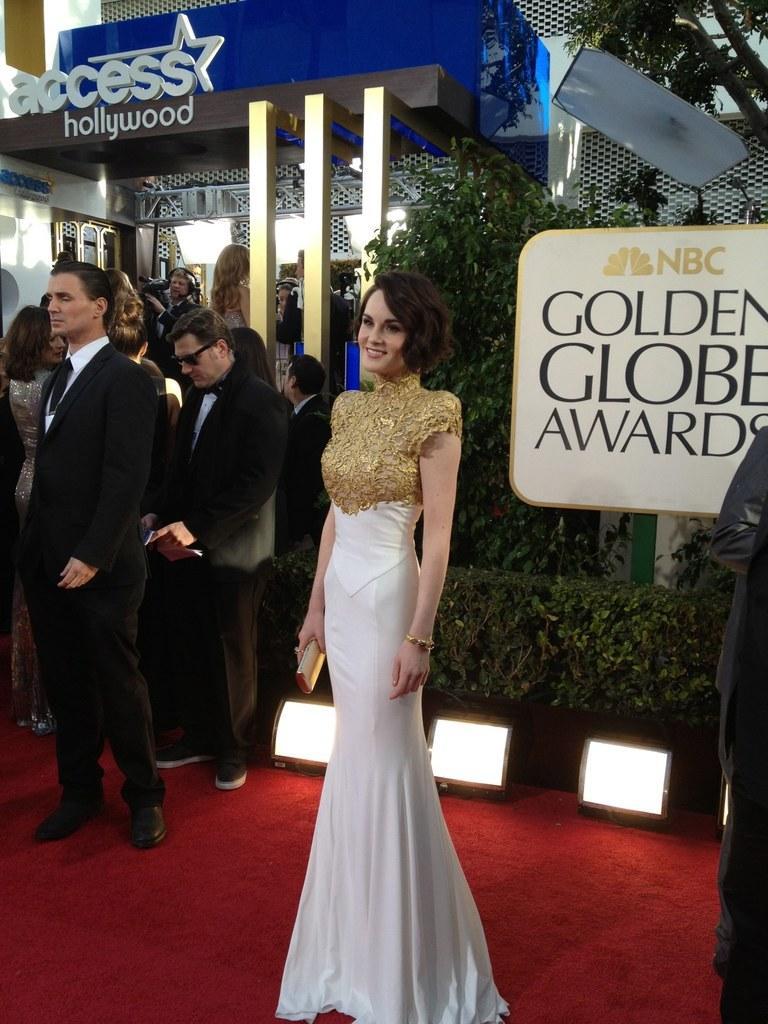How would you summarize this image in a sentence or two? There is one woman standing and wearing a golden and white color dress and holding a wallet in the middle of this image. There is a group of persons standing on the left side of this image, and there are some trees and a board on the right side of this image. There is a building in the background. 